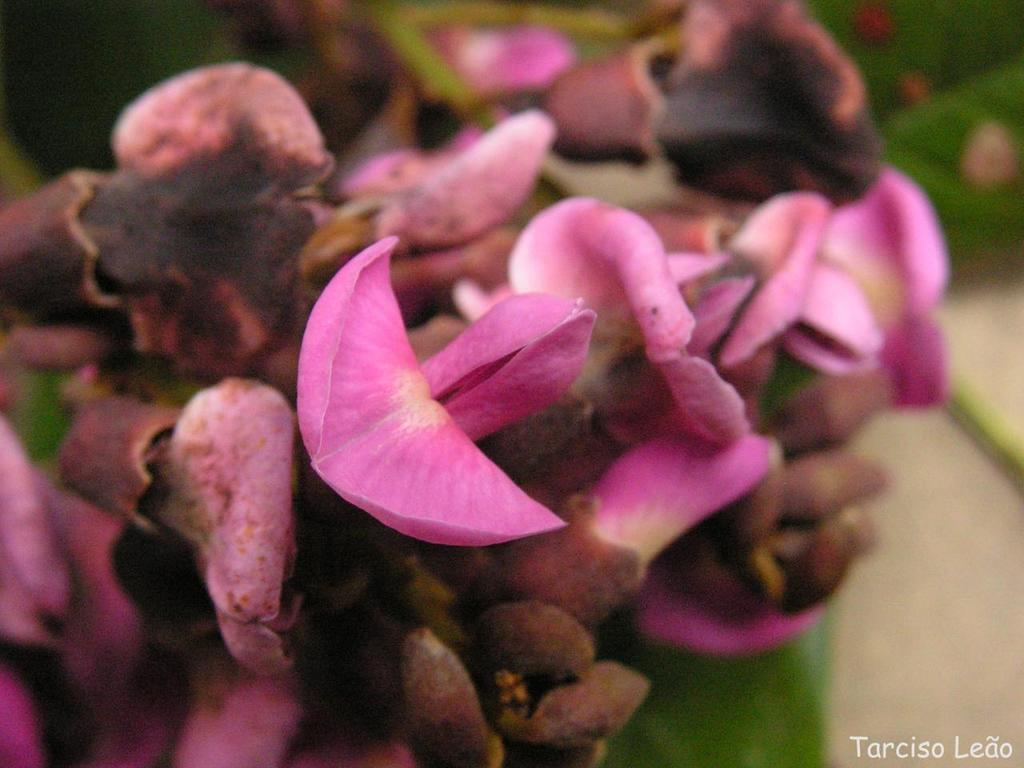What type of living organisms can be seen in the image? There are flowers in the image. Can you describe the background of the image? The background of the image is blurred. Is there any additional information or marking on the image? Yes, there is a watermark on the image. What type of religious symbol can be seen on the mountain in the image? There is no mountain or religious symbol present in the image; it features flowers and a blurred background. How does the sailboat navigate through the water in the image? There is no sailboat or water present in the image; it only contains flowers and a watermark. 